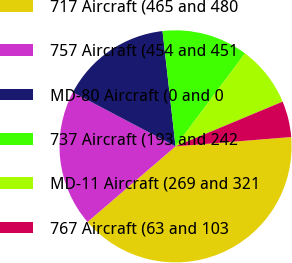Convert chart. <chart><loc_0><loc_0><loc_500><loc_500><pie_chart><fcel>717 Aircraft (465 and 480<fcel>757 Aircraft (454 and 451<fcel>MD-80 Aircraft (0 and 0<fcel>737 Aircraft (193 and 242<fcel>MD-11 Aircraft (269 and 321<fcel>767 Aircraft (63 and 103<nl><fcel>39.99%<fcel>19.0%<fcel>15.5%<fcel>12.0%<fcel>8.5%<fcel>5.01%<nl></chart> 